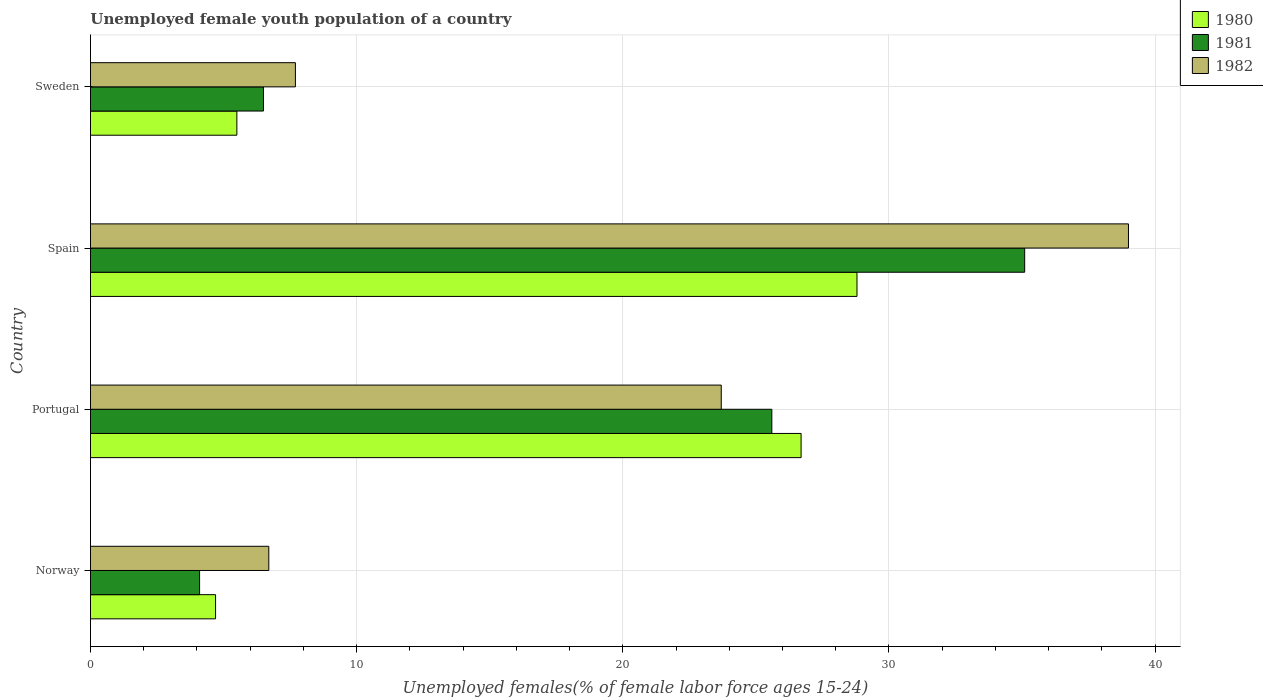How many different coloured bars are there?
Your response must be concise. 3. Are the number of bars on each tick of the Y-axis equal?
Offer a very short reply. Yes. How many bars are there on the 3rd tick from the top?
Provide a succinct answer. 3. What is the percentage of unemployed female youth population in 1981 in Spain?
Your response must be concise. 35.1. Across all countries, what is the maximum percentage of unemployed female youth population in 1981?
Your response must be concise. 35.1. Across all countries, what is the minimum percentage of unemployed female youth population in 1982?
Provide a succinct answer. 6.7. In which country was the percentage of unemployed female youth population in 1982 maximum?
Offer a terse response. Spain. In which country was the percentage of unemployed female youth population in 1981 minimum?
Keep it short and to the point. Norway. What is the total percentage of unemployed female youth population in 1982 in the graph?
Give a very brief answer. 77.1. What is the difference between the percentage of unemployed female youth population in 1980 in Norway and that in Portugal?
Your response must be concise. -22. What is the difference between the percentage of unemployed female youth population in 1982 in Spain and the percentage of unemployed female youth population in 1981 in Portugal?
Provide a short and direct response. 13.4. What is the average percentage of unemployed female youth population in 1981 per country?
Give a very brief answer. 17.82. What is the difference between the percentage of unemployed female youth population in 1982 and percentage of unemployed female youth population in 1980 in Sweden?
Ensure brevity in your answer.  2.2. In how many countries, is the percentage of unemployed female youth population in 1982 greater than 38 %?
Keep it short and to the point. 1. What is the ratio of the percentage of unemployed female youth population in 1982 in Portugal to that in Spain?
Keep it short and to the point. 0.61. Is the percentage of unemployed female youth population in 1982 in Norway less than that in Portugal?
Provide a succinct answer. Yes. Is the difference between the percentage of unemployed female youth population in 1982 in Portugal and Sweden greater than the difference between the percentage of unemployed female youth population in 1980 in Portugal and Sweden?
Keep it short and to the point. No. What is the difference between the highest and the second highest percentage of unemployed female youth population in 1982?
Give a very brief answer. 15.3. What is the difference between the highest and the lowest percentage of unemployed female youth population in 1982?
Your answer should be very brief. 32.3. In how many countries, is the percentage of unemployed female youth population in 1981 greater than the average percentage of unemployed female youth population in 1981 taken over all countries?
Keep it short and to the point. 2. Is the sum of the percentage of unemployed female youth population in 1982 in Spain and Sweden greater than the maximum percentage of unemployed female youth population in 1981 across all countries?
Offer a very short reply. Yes. Is it the case that in every country, the sum of the percentage of unemployed female youth population in 1981 and percentage of unemployed female youth population in 1982 is greater than the percentage of unemployed female youth population in 1980?
Make the answer very short. Yes. How many bars are there?
Give a very brief answer. 12. Are all the bars in the graph horizontal?
Your response must be concise. Yes. How many countries are there in the graph?
Give a very brief answer. 4. What is the difference between two consecutive major ticks on the X-axis?
Offer a terse response. 10. Where does the legend appear in the graph?
Offer a very short reply. Top right. How many legend labels are there?
Keep it short and to the point. 3. How are the legend labels stacked?
Your response must be concise. Vertical. What is the title of the graph?
Give a very brief answer. Unemployed female youth population of a country. What is the label or title of the X-axis?
Ensure brevity in your answer.  Unemployed females(% of female labor force ages 15-24). What is the label or title of the Y-axis?
Keep it short and to the point. Country. What is the Unemployed females(% of female labor force ages 15-24) in 1980 in Norway?
Give a very brief answer. 4.7. What is the Unemployed females(% of female labor force ages 15-24) of 1981 in Norway?
Make the answer very short. 4.1. What is the Unemployed females(% of female labor force ages 15-24) of 1982 in Norway?
Provide a succinct answer. 6.7. What is the Unemployed females(% of female labor force ages 15-24) in 1980 in Portugal?
Your answer should be compact. 26.7. What is the Unemployed females(% of female labor force ages 15-24) in 1981 in Portugal?
Provide a succinct answer. 25.6. What is the Unemployed females(% of female labor force ages 15-24) in 1982 in Portugal?
Offer a terse response. 23.7. What is the Unemployed females(% of female labor force ages 15-24) of 1980 in Spain?
Your answer should be very brief. 28.8. What is the Unemployed females(% of female labor force ages 15-24) in 1981 in Spain?
Provide a short and direct response. 35.1. What is the Unemployed females(% of female labor force ages 15-24) in 1982 in Spain?
Your answer should be very brief. 39. What is the Unemployed females(% of female labor force ages 15-24) in 1980 in Sweden?
Keep it short and to the point. 5.5. What is the Unemployed females(% of female labor force ages 15-24) in 1982 in Sweden?
Offer a terse response. 7.7. Across all countries, what is the maximum Unemployed females(% of female labor force ages 15-24) in 1980?
Offer a terse response. 28.8. Across all countries, what is the maximum Unemployed females(% of female labor force ages 15-24) of 1981?
Provide a short and direct response. 35.1. Across all countries, what is the maximum Unemployed females(% of female labor force ages 15-24) in 1982?
Provide a succinct answer. 39. Across all countries, what is the minimum Unemployed females(% of female labor force ages 15-24) in 1980?
Your answer should be compact. 4.7. Across all countries, what is the minimum Unemployed females(% of female labor force ages 15-24) of 1981?
Offer a very short reply. 4.1. Across all countries, what is the minimum Unemployed females(% of female labor force ages 15-24) of 1982?
Your answer should be very brief. 6.7. What is the total Unemployed females(% of female labor force ages 15-24) of 1980 in the graph?
Ensure brevity in your answer.  65.7. What is the total Unemployed females(% of female labor force ages 15-24) in 1981 in the graph?
Your answer should be compact. 71.3. What is the total Unemployed females(% of female labor force ages 15-24) of 1982 in the graph?
Provide a succinct answer. 77.1. What is the difference between the Unemployed females(% of female labor force ages 15-24) of 1980 in Norway and that in Portugal?
Your answer should be very brief. -22. What is the difference between the Unemployed females(% of female labor force ages 15-24) of 1981 in Norway and that in Portugal?
Make the answer very short. -21.5. What is the difference between the Unemployed females(% of female labor force ages 15-24) of 1982 in Norway and that in Portugal?
Offer a terse response. -17. What is the difference between the Unemployed females(% of female labor force ages 15-24) in 1980 in Norway and that in Spain?
Offer a very short reply. -24.1. What is the difference between the Unemployed females(% of female labor force ages 15-24) in 1981 in Norway and that in Spain?
Keep it short and to the point. -31. What is the difference between the Unemployed females(% of female labor force ages 15-24) in 1982 in Norway and that in Spain?
Your response must be concise. -32.3. What is the difference between the Unemployed females(% of female labor force ages 15-24) in 1981 in Norway and that in Sweden?
Make the answer very short. -2.4. What is the difference between the Unemployed females(% of female labor force ages 15-24) of 1982 in Norway and that in Sweden?
Provide a short and direct response. -1. What is the difference between the Unemployed females(% of female labor force ages 15-24) in 1981 in Portugal and that in Spain?
Your answer should be compact. -9.5. What is the difference between the Unemployed females(% of female labor force ages 15-24) of 1982 in Portugal and that in Spain?
Offer a terse response. -15.3. What is the difference between the Unemployed females(% of female labor force ages 15-24) in 1980 in Portugal and that in Sweden?
Make the answer very short. 21.2. What is the difference between the Unemployed females(% of female labor force ages 15-24) of 1980 in Spain and that in Sweden?
Ensure brevity in your answer.  23.3. What is the difference between the Unemployed females(% of female labor force ages 15-24) in 1981 in Spain and that in Sweden?
Provide a short and direct response. 28.6. What is the difference between the Unemployed females(% of female labor force ages 15-24) in 1982 in Spain and that in Sweden?
Your response must be concise. 31.3. What is the difference between the Unemployed females(% of female labor force ages 15-24) in 1980 in Norway and the Unemployed females(% of female labor force ages 15-24) in 1981 in Portugal?
Your answer should be very brief. -20.9. What is the difference between the Unemployed females(% of female labor force ages 15-24) in 1981 in Norway and the Unemployed females(% of female labor force ages 15-24) in 1982 in Portugal?
Ensure brevity in your answer.  -19.6. What is the difference between the Unemployed females(% of female labor force ages 15-24) of 1980 in Norway and the Unemployed females(% of female labor force ages 15-24) of 1981 in Spain?
Ensure brevity in your answer.  -30.4. What is the difference between the Unemployed females(% of female labor force ages 15-24) of 1980 in Norway and the Unemployed females(% of female labor force ages 15-24) of 1982 in Spain?
Make the answer very short. -34.3. What is the difference between the Unemployed females(% of female labor force ages 15-24) in 1981 in Norway and the Unemployed females(% of female labor force ages 15-24) in 1982 in Spain?
Keep it short and to the point. -34.9. What is the difference between the Unemployed females(% of female labor force ages 15-24) of 1980 in Norway and the Unemployed females(% of female labor force ages 15-24) of 1981 in Sweden?
Ensure brevity in your answer.  -1.8. What is the difference between the Unemployed females(% of female labor force ages 15-24) of 1981 in Norway and the Unemployed females(% of female labor force ages 15-24) of 1982 in Sweden?
Your answer should be very brief. -3.6. What is the difference between the Unemployed females(% of female labor force ages 15-24) of 1980 in Portugal and the Unemployed females(% of female labor force ages 15-24) of 1981 in Spain?
Offer a terse response. -8.4. What is the difference between the Unemployed females(% of female labor force ages 15-24) in 1981 in Portugal and the Unemployed females(% of female labor force ages 15-24) in 1982 in Spain?
Ensure brevity in your answer.  -13.4. What is the difference between the Unemployed females(% of female labor force ages 15-24) in 1980 in Portugal and the Unemployed females(% of female labor force ages 15-24) in 1981 in Sweden?
Provide a short and direct response. 20.2. What is the difference between the Unemployed females(% of female labor force ages 15-24) of 1980 in Spain and the Unemployed females(% of female labor force ages 15-24) of 1981 in Sweden?
Offer a terse response. 22.3. What is the difference between the Unemployed females(% of female labor force ages 15-24) in 1980 in Spain and the Unemployed females(% of female labor force ages 15-24) in 1982 in Sweden?
Make the answer very short. 21.1. What is the difference between the Unemployed females(% of female labor force ages 15-24) of 1981 in Spain and the Unemployed females(% of female labor force ages 15-24) of 1982 in Sweden?
Make the answer very short. 27.4. What is the average Unemployed females(% of female labor force ages 15-24) of 1980 per country?
Your response must be concise. 16.43. What is the average Unemployed females(% of female labor force ages 15-24) in 1981 per country?
Offer a terse response. 17.82. What is the average Unemployed females(% of female labor force ages 15-24) in 1982 per country?
Your response must be concise. 19.27. What is the difference between the Unemployed females(% of female labor force ages 15-24) in 1980 and Unemployed females(% of female labor force ages 15-24) in 1982 in Norway?
Offer a very short reply. -2. What is the difference between the Unemployed females(% of female labor force ages 15-24) in 1980 and Unemployed females(% of female labor force ages 15-24) in 1981 in Portugal?
Your answer should be compact. 1.1. What is the difference between the Unemployed females(% of female labor force ages 15-24) of 1980 and Unemployed females(% of female labor force ages 15-24) of 1981 in Spain?
Your answer should be very brief. -6.3. What is the difference between the Unemployed females(% of female labor force ages 15-24) in 1980 and Unemployed females(% of female labor force ages 15-24) in 1982 in Spain?
Make the answer very short. -10.2. What is the difference between the Unemployed females(% of female labor force ages 15-24) in 1980 and Unemployed females(% of female labor force ages 15-24) in 1982 in Sweden?
Your answer should be compact. -2.2. What is the difference between the Unemployed females(% of female labor force ages 15-24) in 1981 and Unemployed females(% of female labor force ages 15-24) in 1982 in Sweden?
Offer a very short reply. -1.2. What is the ratio of the Unemployed females(% of female labor force ages 15-24) of 1980 in Norway to that in Portugal?
Keep it short and to the point. 0.18. What is the ratio of the Unemployed females(% of female labor force ages 15-24) in 1981 in Norway to that in Portugal?
Offer a terse response. 0.16. What is the ratio of the Unemployed females(% of female labor force ages 15-24) of 1982 in Norway to that in Portugal?
Make the answer very short. 0.28. What is the ratio of the Unemployed females(% of female labor force ages 15-24) in 1980 in Norway to that in Spain?
Ensure brevity in your answer.  0.16. What is the ratio of the Unemployed females(% of female labor force ages 15-24) in 1981 in Norway to that in Spain?
Make the answer very short. 0.12. What is the ratio of the Unemployed females(% of female labor force ages 15-24) of 1982 in Norway to that in Spain?
Offer a very short reply. 0.17. What is the ratio of the Unemployed females(% of female labor force ages 15-24) of 1980 in Norway to that in Sweden?
Offer a very short reply. 0.85. What is the ratio of the Unemployed females(% of female labor force ages 15-24) in 1981 in Norway to that in Sweden?
Your answer should be compact. 0.63. What is the ratio of the Unemployed females(% of female labor force ages 15-24) of 1982 in Norway to that in Sweden?
Give a very brief answer. 0.87. What is the ratio of the Unemployed females(% of female labor force ages 15-24) in 1980 in Portugal to that in Spain?
Offer a terse response. 0.93. What is the ratio of the Unemployed females(% of female labor force ages 15-24) in 1981 in Portugal to that in Spain?
Ensure brevity in your answer.  0.73. What is the ratio of the Unemployed females(% of female labor force ages 15-24) of 1982 in Portugal to that in Spain?
Keep it short and to the point. 0.61. What is the ratio of the Unemployed females(% of female labor force ages 15-24) in 1980 in Portugal to that in Sweden?
Your answer should be very brief. 4.85. What is the ratio of the Unemployed females(% of female labor force ages 15-24) of 1981 in Portugal to that in Sweden?
Provide a succinct answer. 3.94. What is the ratio of the Unemployed females(% of female labor force ages 15-24) in 1982 in Portugal to that in Sweden?
Provide a short and direct response. 3.08. What is the ratio of the Unemployed females(% of female labor force ages 15-24) of 1980 in Spain to that in Sweden?
Provide a succinct answer. 5.24. What is the ratio of the Unemployed females(% of female labor force ages 15-24) of 1981 in Spain to that in Sweden?
Make the answer very short. 5.4. What is the ratio of the Unemployed females(% of female labor force ages 15-24) in 1982 in Spain to that in Sweden?
Offer a terse response. 5.06. What is the difference between the highest and the second highest Unemployed females(% of female labor force ages 15-24) in 1981?
Your response must be concise. 9.5. What is the difference between the highest and the lowest Unemployed females(% of female labor force ages 15-24) of 1980?
Your answer should be compact. 24.1. What is the difference between the highest and the lowest Unemployed females(% of female labor force ages 15-24) of 1982?
Give a very brief answer. 32.3. 